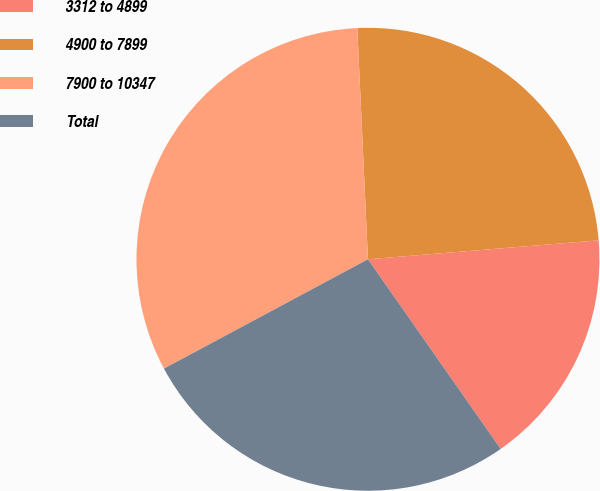Convert chart to OTSL. <chart><loc_0><loc_0><loc_500><loc_500><pie_chart><fcel>3312 to 4899<fcel>4900 to 7899<fcel>7900 to 10347<fcel>Total<nl><fcel>16.59%<fcel>24.43%<fcel>32.1%<fcel>26.89%<nl></chart> 